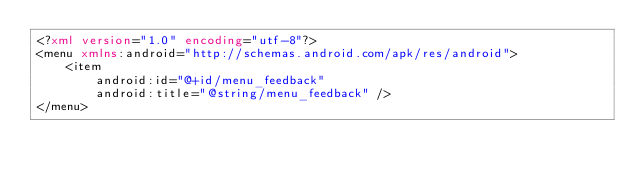Convert code to text. <code><loc_0><loc_0><loc_500><loc_500><_XML_><?xml version="1.0" encoding="utf-8"?>
<menu xmlns:android="http://schemas.android.com/apk/res/android">
    <item
        android:id="@+id/menu_feedback"
        android:title="@string/menu_feedback" />
</menu>
</code> 